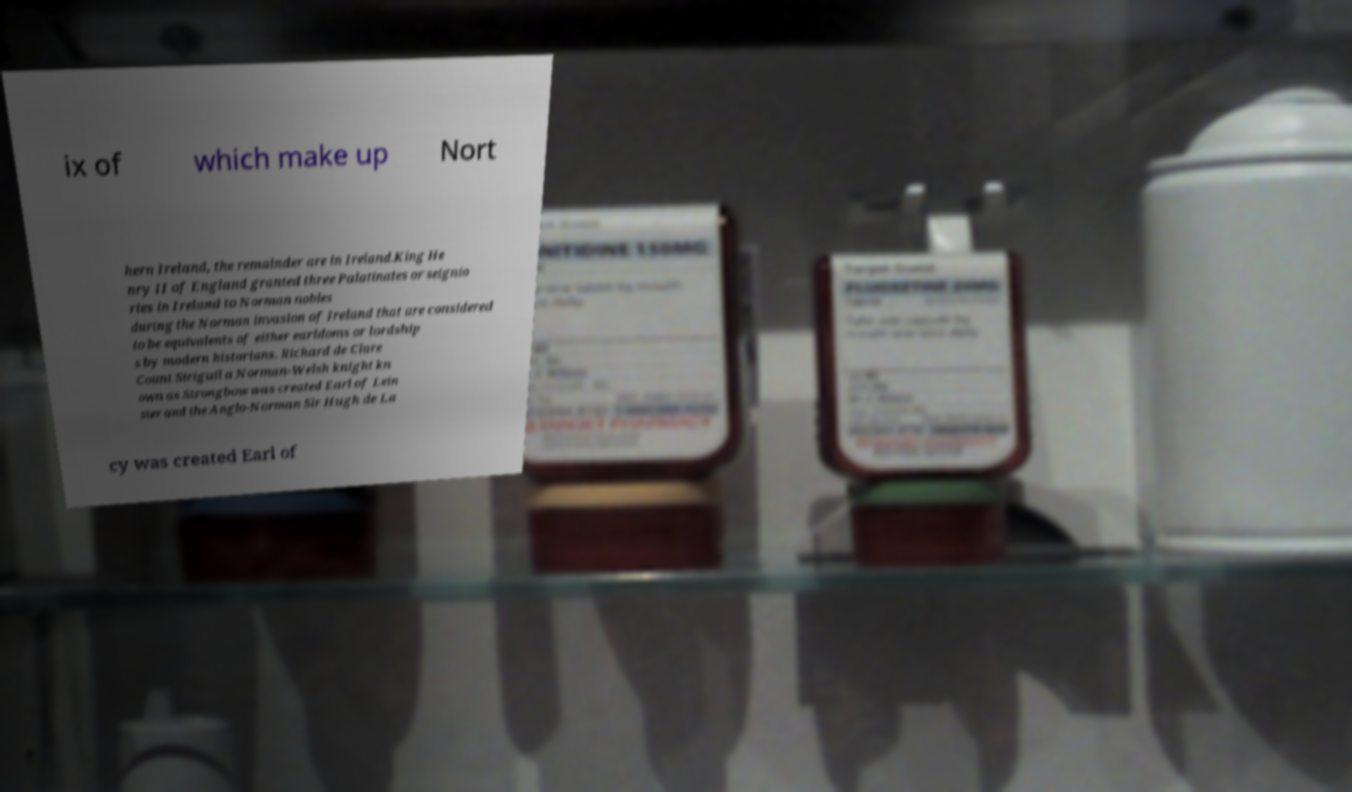Could you extract and type out the text from this image? ix of which make up Nort hern Ireland, the remainder are in Ireland.King He nry II of England granted three Palatinates or seignio ries in Ireland to Norman nobles during the Norman invasion of Ireland that are considered to be equivalents of either earldoms or lordship s by modern historians. Richard de Clare Count Striguil a Norman-Welsh knight kn own as Strongbow was created Earl of Lein ster and the Anglo-Norman Sir Hugh de La cy was created Earl of 